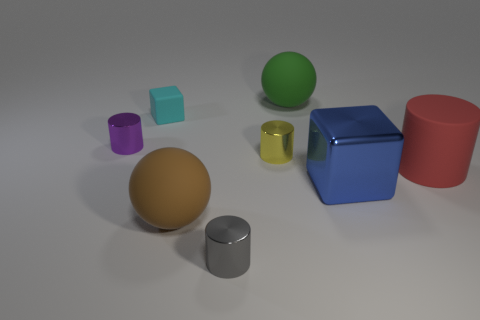What size is the other thing that is the same shape as the big green thing?
Your answer should be compact. Large. Is there anything else that has the same size as the cyan rubber cube?
Ensure brevity in your answer.  Yes. What is the block that is on the right side of the cylinder in front of the large blue object made of?
Offer a very short reply. Metal. How many rubber things are yellow cylinders or big green objects?
Ensure brevity in your answer.  1. What color is the big rubber object that is the same shape as the small purple metal thing?
Provide a succinct answer. Red. How many large metallic things are the same color as the matte cylinder?
Ensure brevity in your answer.  0. There is a matte ball that is in front of the large green object; are there any big blue objects that are to the left of it?
Make the answer very short. No. How many objects are both right of the big brown object and in front of the large blue cube?
Offer a very short reply. 1. What number of gray blocks have the same material as the tiny gray thing?
Provide a succinct answer. 0. How big is the thing that is in front of the large ball that is in front of the green rubber ball?
Keep it short and to the point. Small. 